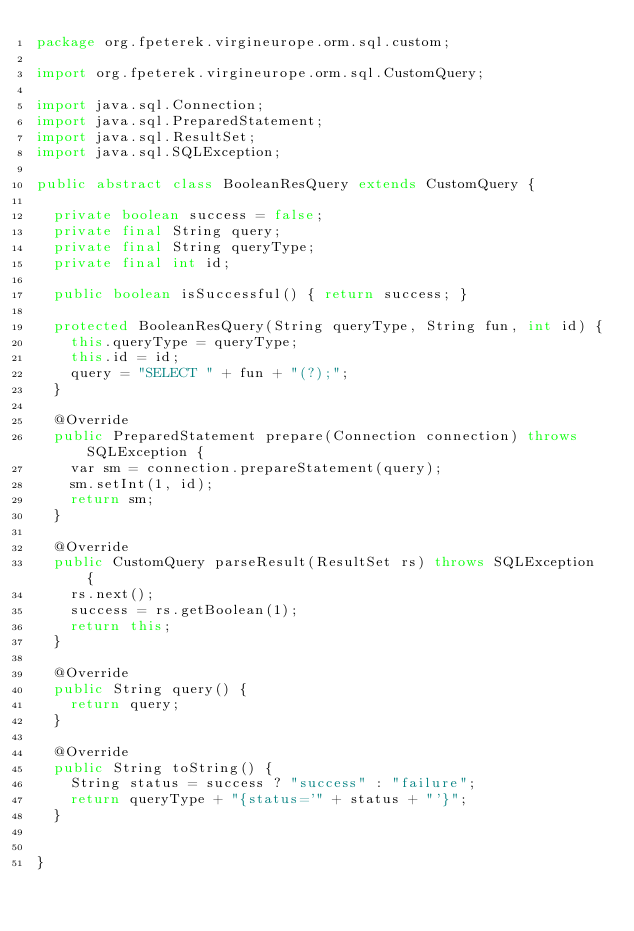Convert code to text. <code><loc_0><loc_0><loc_500><loc_500><_Java_>package org.fpeterek.virgineurope.orm.sql.custom;

import org.fpeterek.virgineurope.orm.sql.CustomQuery;

import java.sql.Connection;
import java.sql.PreparedStatement;
import java.sql.ResultSet;
import java.sql.SQLException;

public abstract class BooleanResQuery extends CustomQuery {

  private boolean success = false;
  private final String query;
  private final String queryType;
  private final int id;

  public boolean isSuccessful() { return success; }

  protected BooleanResQuery(String queryType, String fun, int id) {
    this.queryType = queryType;
    this.id = id;
    query = "SELECT " + fun + "(?);";
  }

  @Override
  public PreparedStatement prepare(Connection connection) throws SQLException {
    var sm = connection.prepareStatement(query);
    sm.setInt(1, id);
    return sm;
  }

  @Override
  public CustomQuery parseResult(ResultSet rs) throws SQLException {
    rs.next();
    success = rs.getBoolean(1);
    return this;
  }

  @Override
  public String query() {
    return query;
  }

  @Override
  public String toString() {
    String status = success ? "success" : "failure";
    return queryType + "{status='" + status + "'}";
  }


}
</code> 